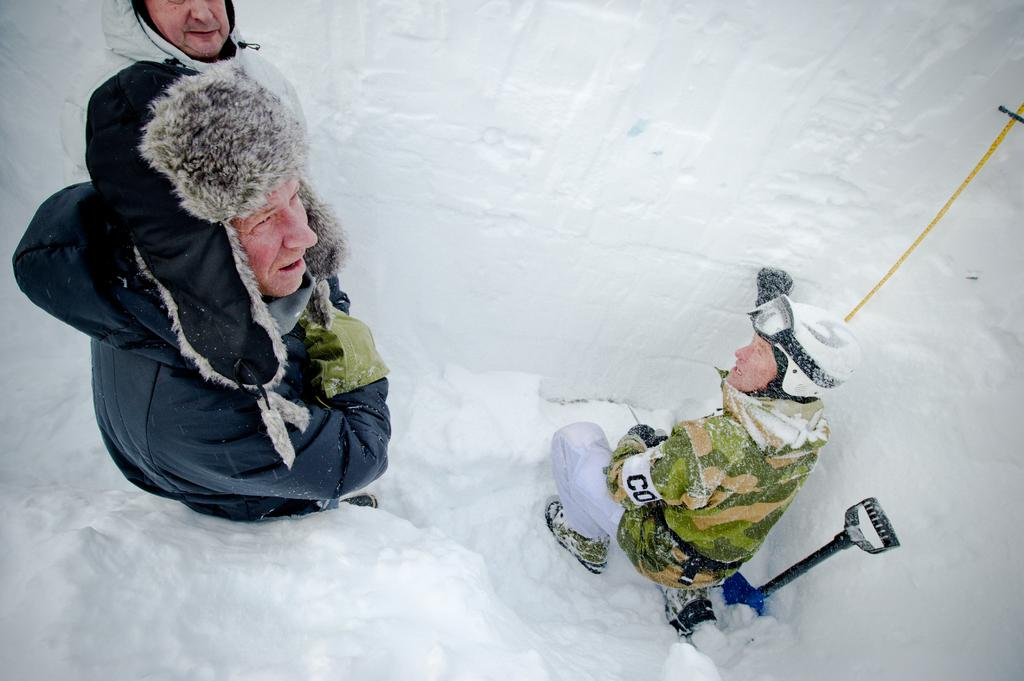How many people are in the image? There are persons in the image, but the exact number is not specified. What is the surface the persons are standing on? The persons are on the snow. What else can be seen on the snow in the image? There is a stand on the snow. What type of net is being used by the persons in the image? There is no mention of a net in the image, so it cannot be determined if one is being used. 